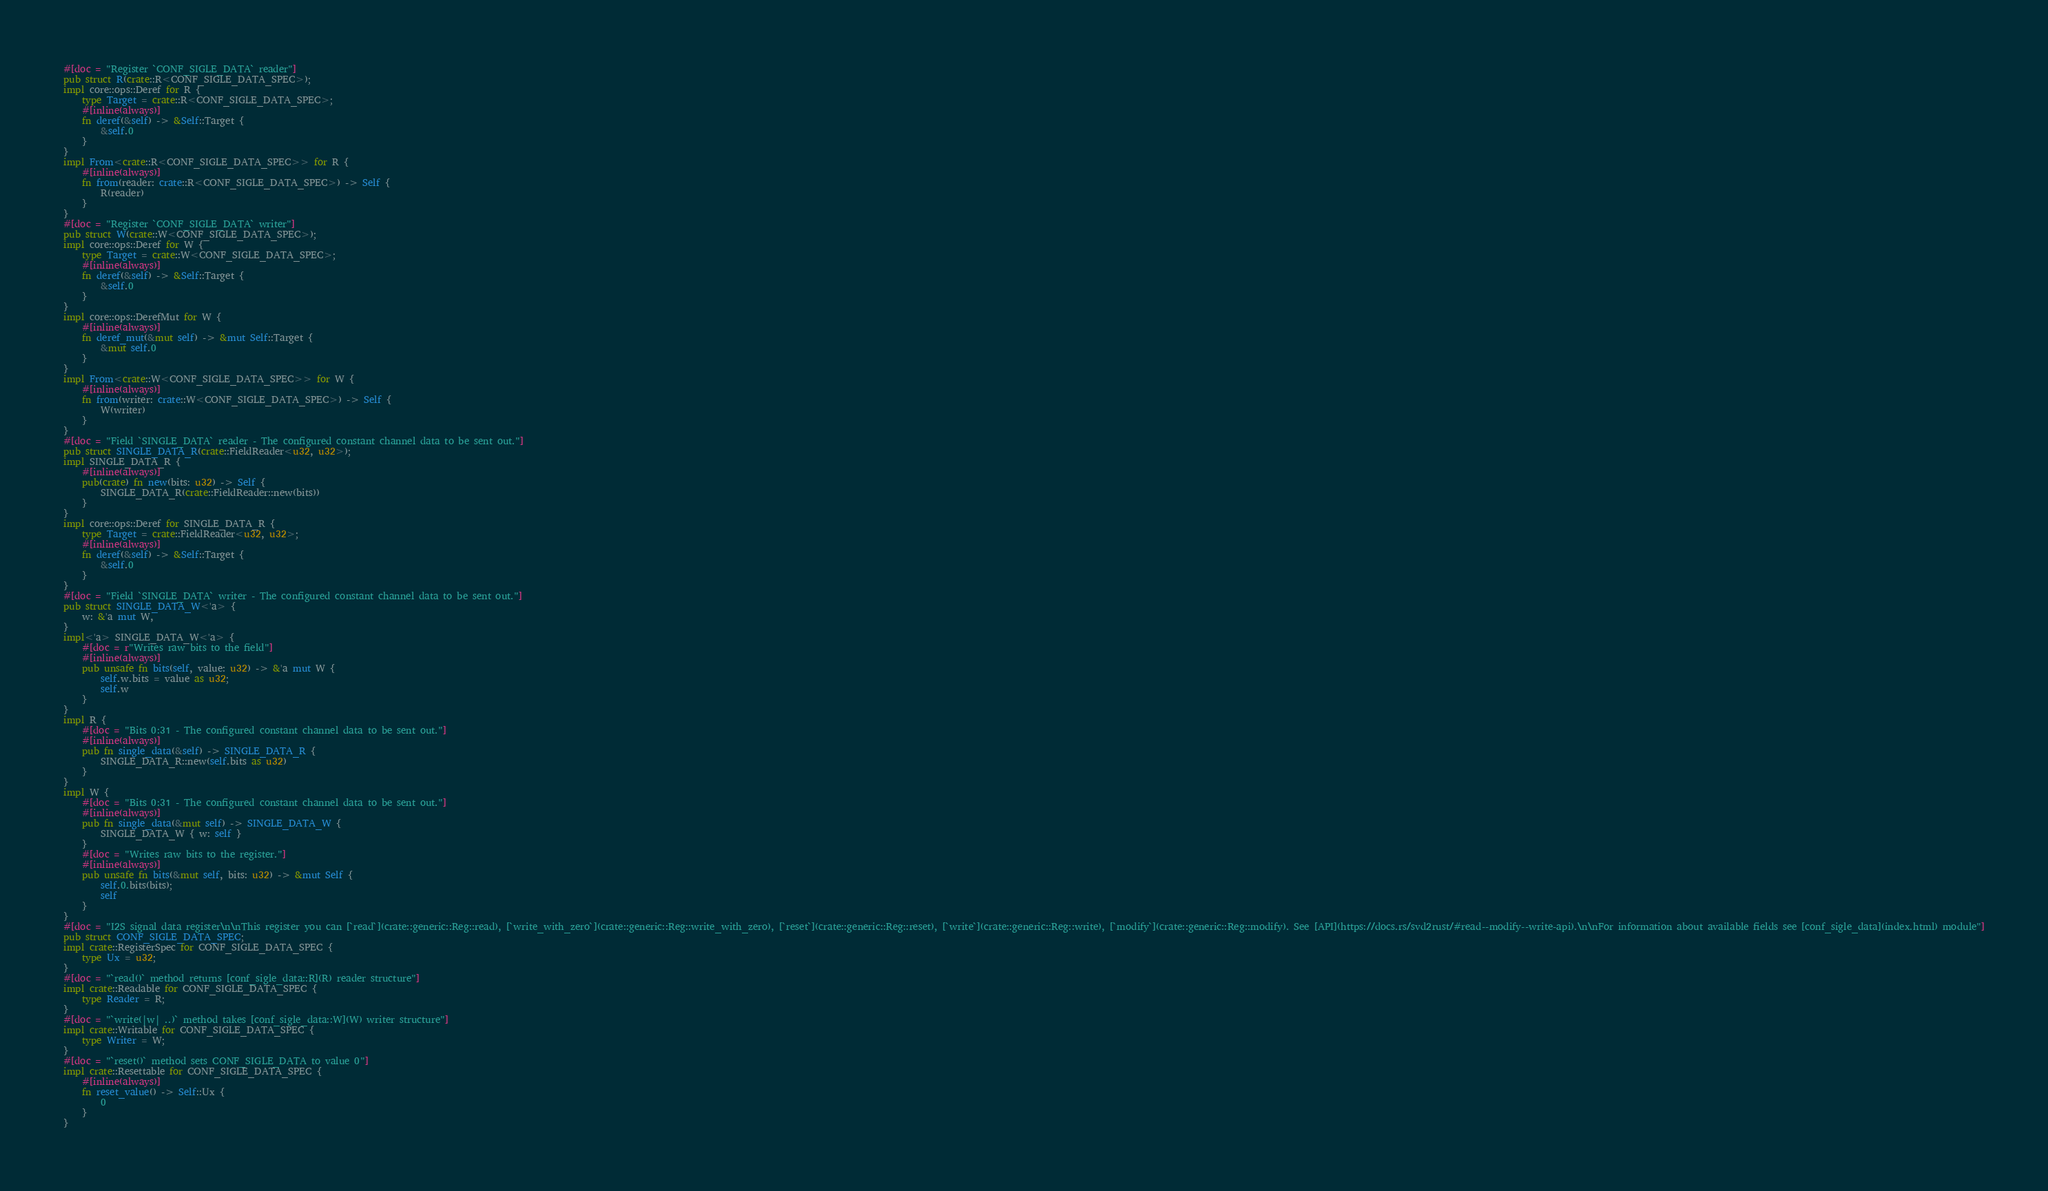<code> <loc_0><loc_0><loc_500><loc_500><_Rust_>#[doc = "Register `CONF_SIGLE_DATA` reader"]
pub struct R(crate::R<CONF_SIGLE_DATA_SPEC>);
impl core::ops::Deref for R {
    type Target = crate::R<CONF_SIGLE_DATA_SPEC>;
    #[inline(always)]
    fn deref(&self) -> &Self::Target {
        &self.0
    }
}
impl From<crate::R<CONF_SIGLE_DATA_SPEC>> for R {
    #[inline(always)]
    fn from(reader: crate::R<CONF_SIGLE_DATA_SPEC>) -> Self {
        R(reader)
    }
}
#[doc = "Register `CONF_SIGLE_DATA` writer"]
pub struct W(crate::W<CONF_SIGLE_DATA_SPEC>);
impl core::ops::Deref for W {
    type Target = crate::W<CONF_SIGLE_DATA_SPEC>;
    #[inline(always)]
    fn deref(&self) -> &Self::Target {
        &self.0
    }
}
impl core::ops::DerefMut for W {
    #[inline(always)]
    fn deref_mut(&mut self) -> &mut Self::Target {
        &mut self.0
    }
}
impl From<crate::W<CONF_SIGLE_DATA_SPEC>> for W {
    #[inline(always)]
    fn from(writer: crate::W<CONF_SIGLE_DATA_SPEC>) -> Self {
        W(writer)
    }
}
#[doc = "Field `SINGLE_DATA` reader - The configured constant channel data to be sent out."]
pub struct SINGLE_DATA_R(crate::FieldReader<u32, u32>);
impl SINGLE_DATA_R {
    #[inline(always)]
    pub(crate) fn new(bits: u32) -> Self {
        SINGLE_DATA_R(crate::FieldReader::new(bits))
    }
}
impl core::ops::Deref for SINGLE_DATA_R {
    type Target = crate::FieldReader<u32, u32>;
    #[inline(always)]
    fn deref(&self) -> &Self::Target {
        &self.0
    }
}
#[doc = "Field `SINGLE_DATA` writer - The configured constant channel data to be sent out."]
pub struct SINGLE_DATA_W<'a> {
    w: &'a mut W,
}
impl<'a> SINGLE_DATA_W<'a> {
    #[doc = r"Writes raw bits to the field"]
    #[inline(always)]
    pub unsafe fn bits(self, value: u32) -> &'a mut W {
        self.w.bits = value as u32;
        self.w
    }
}
impl R {
    #[doc = "Bits 0:31 - The configured constant channel data to be sent out."]
    #[inline(always)]
    pub fn single_data(&self) -> SINGLE_DATA_R {
        SINGLE_DATA_R::new(self.bits as u32)
    }
}
impl W {
    #[doc = "Bits 0:31 - The configured constant channel data to be sent out."]
    #[inline(always)]
    pub fn single_data(&mut self) -> SINGLE_DATA_W {
        SINGLE_DATA_W { w: self }
    }
    #[doc = "Writes raw bits to the register."]
    #[inline(always)]
    pub unsafe fn bits(&mut self, bits: u32) -> &mut Self {
        self.0.bits(bits);
        self
    }
}
#[doc = "I2S signal data register\n\nThis register you can [`read`](crate::generic::Reg::read), [`write_with_zero`](crate::generic::Reg::write_with_zero), [`reset`](crate::generic::Reg::reset), [`write`](crate::generic::Reg::write), [`modify`](crate::generic::Reg::modify). See [API](https://docs.rs/svd2rust/#read--modify--write-api).\n\nFor information about available fields see [conf_sigle_data](index.html) module"]
pub struct CONF_SIGLE_DATA_SPEC;
impl crate::RegisterSpec for CONF_SIGLE_DATA_SPEC {
    type Ux = u32;
}
#[doc = "`read()` method returns [conf_sigle_data::R](R) reader structure"]
impl crate::Readable for CONF_SIGLE_DATA_SPEC {
    type Reader = R;
}
#[doc = "`write(|w| ..)` method takes [conf_sigle_data::W](W) writer structure"]
impl crate::Writable for CONF_SIGLE_DATA_SPEC {
    type Writer = W;
}
#[doc = "`reset()` method sets CONF_SIGLE_DATA to value 0"]
impl crate::Resettable for CONF_SIGLE_DATA_SPEC {
    #[inline(always)]
    fn reset_value() -> Self::Ux {
        0
    }
}
</code> 